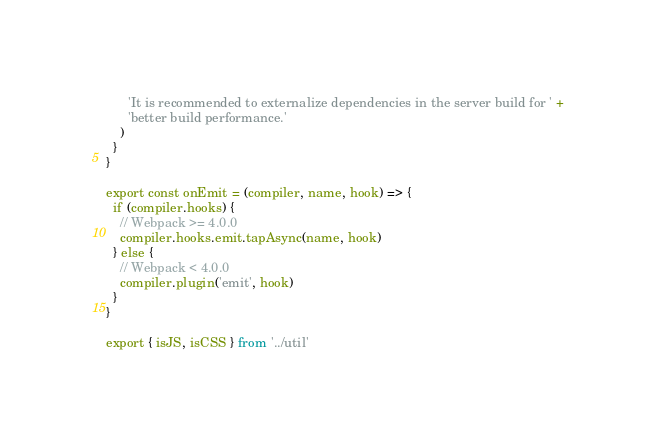<code> <loc_0><loc_0><loc_500><loc_500><_JavaScript_>      'It is recommended to externalize dependencies in the server build for ' +
      'better build performance.'
    )
  }
}

export const onEmit = (compiler, name, hook) => {
  if (compiler.hooks) {
    // Webpack >= 4.0.0
    compiler.hooks.emit.tapAsync(name, hook)
  } else {
    // Webpack < 4.0.0
    compiler.plugin('emit', hook)
  }
}

export { isJS, isCSS } from '../util'
</code> 